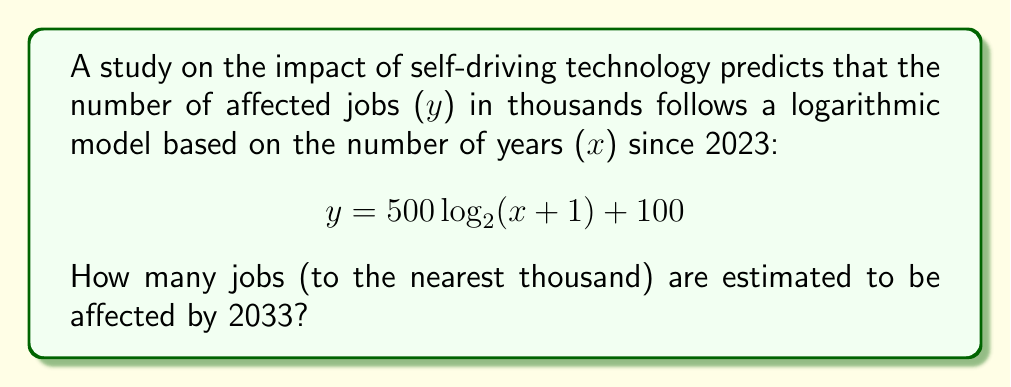Teach me how to tackle this problem. To solve this problem, we need to follow these steps:

1) Identify the given information:
   - The model is $y = 500 \log_2(x+1) + 100$
   - y is the number of affected jobs in thousands
   - x is the number of years since 2023
   - We need to find y for the year 2033

2) Calculate x:
   2033 - 2023 = 10 years

3) Substitute x = 10 into the equation:
   $y = 500 \log_2(10+1) + 100$

4) Simplify:
   $y = 500 \log_2(11) + 100$

5) Calculate $\log_2(11)$:
   $\log_2(11) \approx 3.4594$

6) Multiply by 500:
   $500 * 3.4594 = 1729.7$

7) Add 100:
   $1729.7 + 100 = 1829.7$

8) Round to the nearest thousand:
   1829.7 rounds to 1830

Therefore, approximately 1,830,000 jobs are estimated to be affected by 2033.
Answer: 1,830,000 jobs 